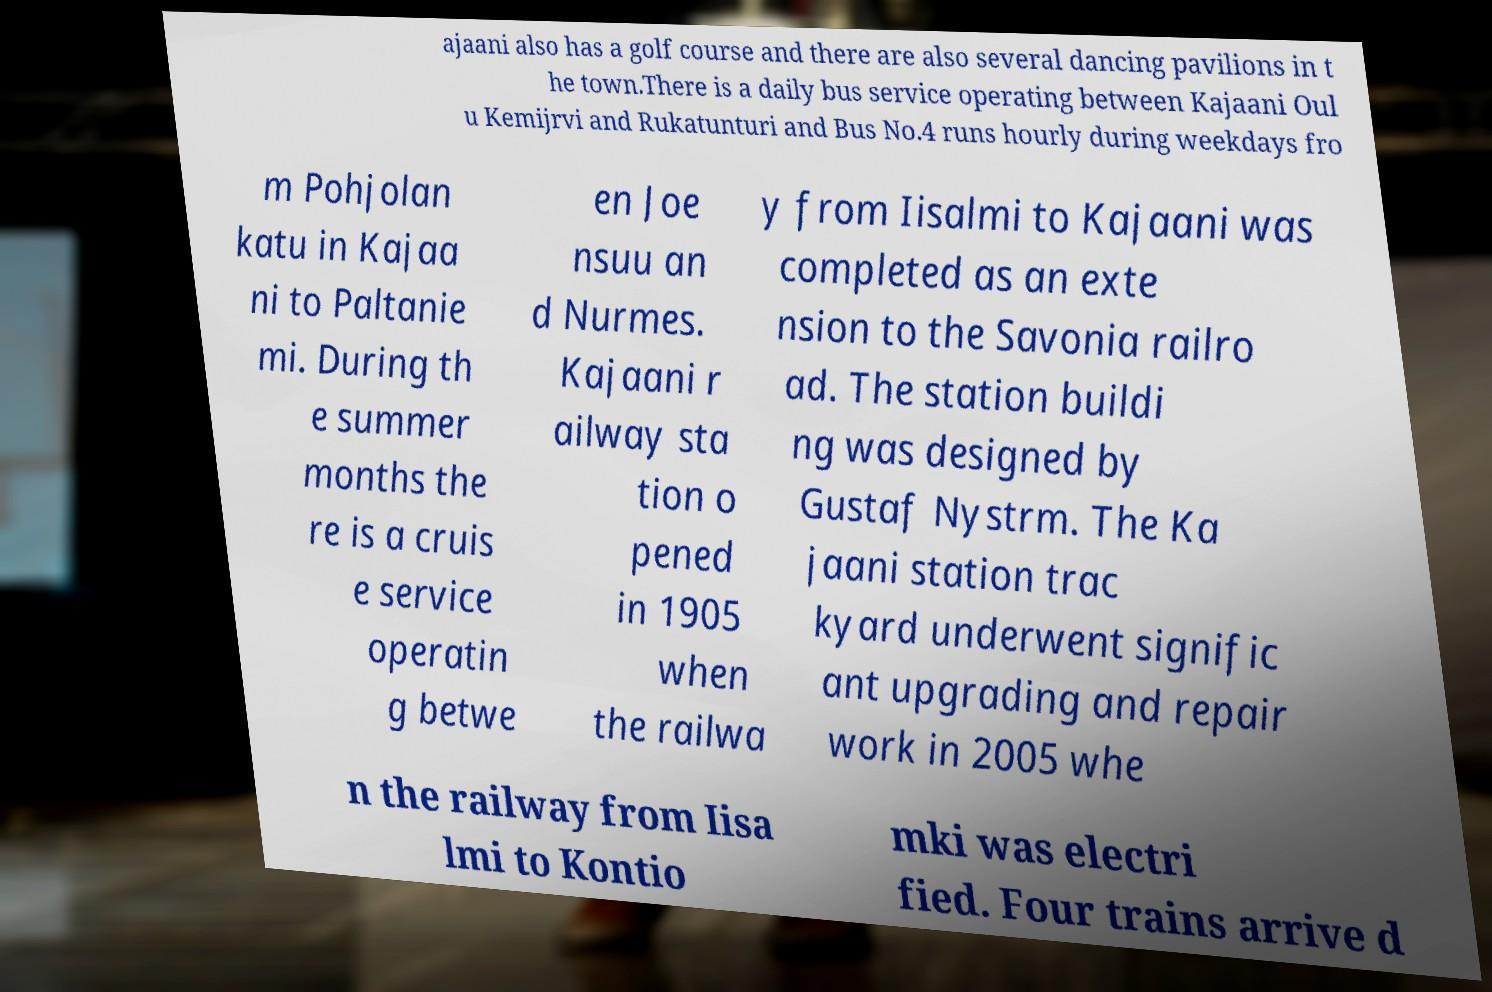What messages or text are displayed in this image? I need them in a readable, typed format. ajaani also has a golf course and there are also several dancing pavilions in t he town.There is a daily bus service operating between Kajaani Oul u Kemijrvi and Rukatunturi and Bus No.4 runs hourly during weekdays fro m Pohjolan katu in Kajaa ni to Paltanie mi. During th e summer months the re is a cruis e service operatin g betwe en Joe nsuu an d Nurmes. Kajaani r ailway sta tion o pened in 1905 when the railwa y from Iisalmi to Kajaani was completed as an exte nsion to the Savonia railro ad. The station buildi ng was designed by Gustaf Nystrm. The Ka jaani station trac kyard underwent signific ant upgrading and repair work in 2005 whe n the railway from Iisa lmi to Kontio mki was electri fied. Four trains arrive d 